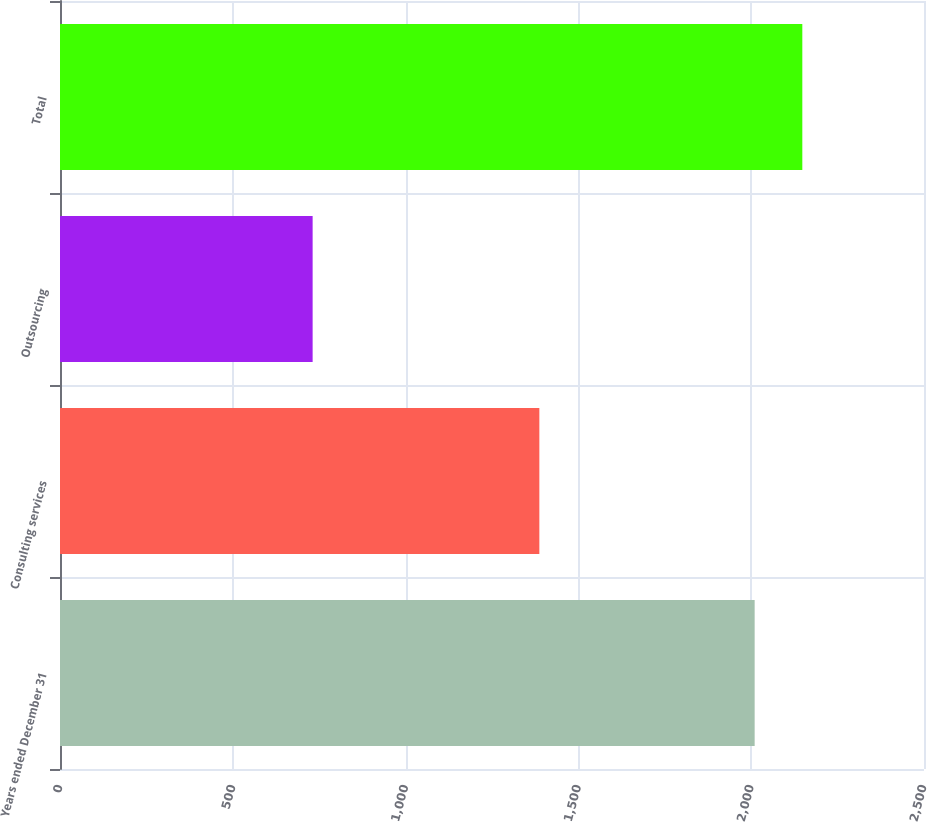Convert chart to OTSL. <chart><loc_0><loc_0><loc_500><loc_500><bar_chart><fcel>Years ended December 31<fcel>Consulting services<fcel>Outsourcing<fcel>Total<nl><fcel>2010<fcel>1387<fcel>731<fcel>2147.9<nl></chart> 